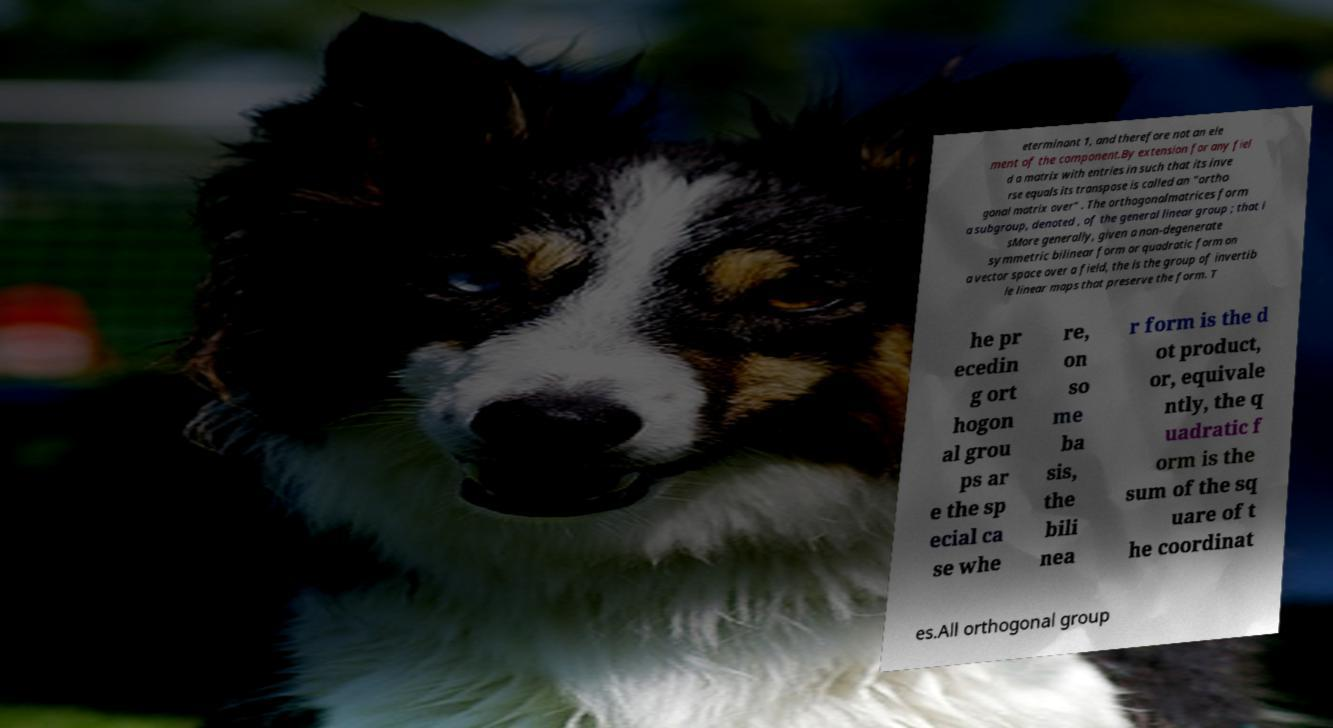Could you extract and type out the text from this image? eterminant 1, and therefore not an ele ment of the component.By extension for any fiel d a matrix with entries in such that its inve rse equals its transpose is called an "ortho gonal matrix over" . The orthogonalmatrices form a subgroup, denoted , of the general linear group ; that i sMore generally, given a non-degenerate symmetric bilinear form or quadratic form on a vector space over a field, the is the group of invertib le linear maps that preserve the form. T he pr ecedin g ort hogon al grou ps ar e the sp ecial ca se whe re, on so me ba sis, the bili nea r form is the d ot product, or, equivale ntly, the q uadratic f orm is the sum of the sq uare of t he coordinat es.All orthogonal group 